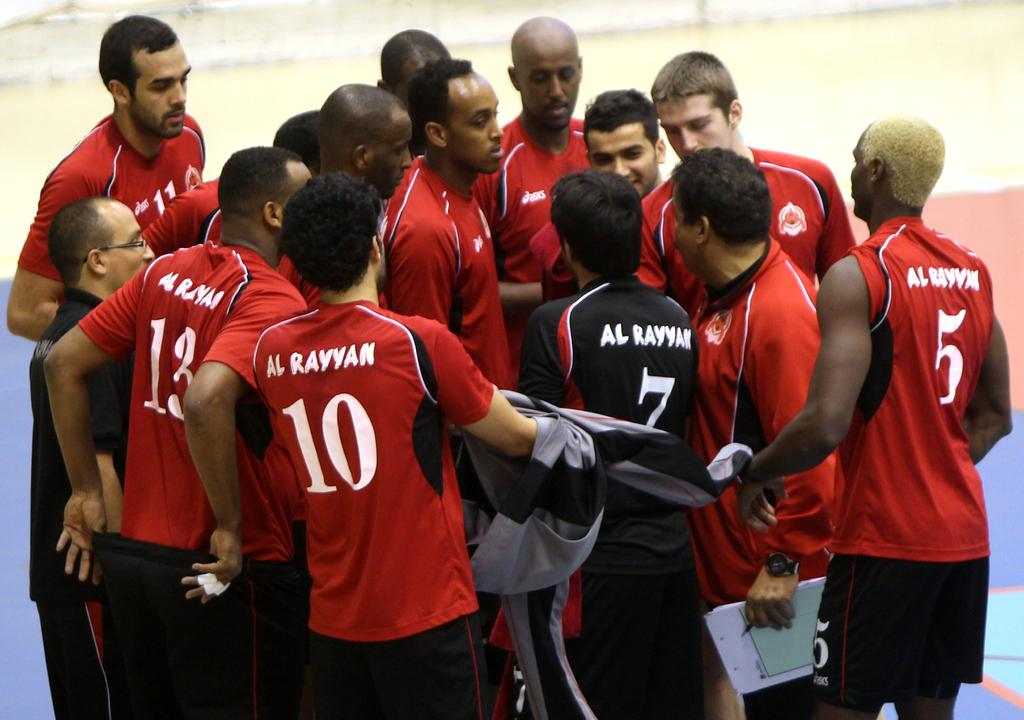<image>
Give a short and clear explanation of the subsequent image. Player number 13, 10 and 5 are on the outside of the huddle. 